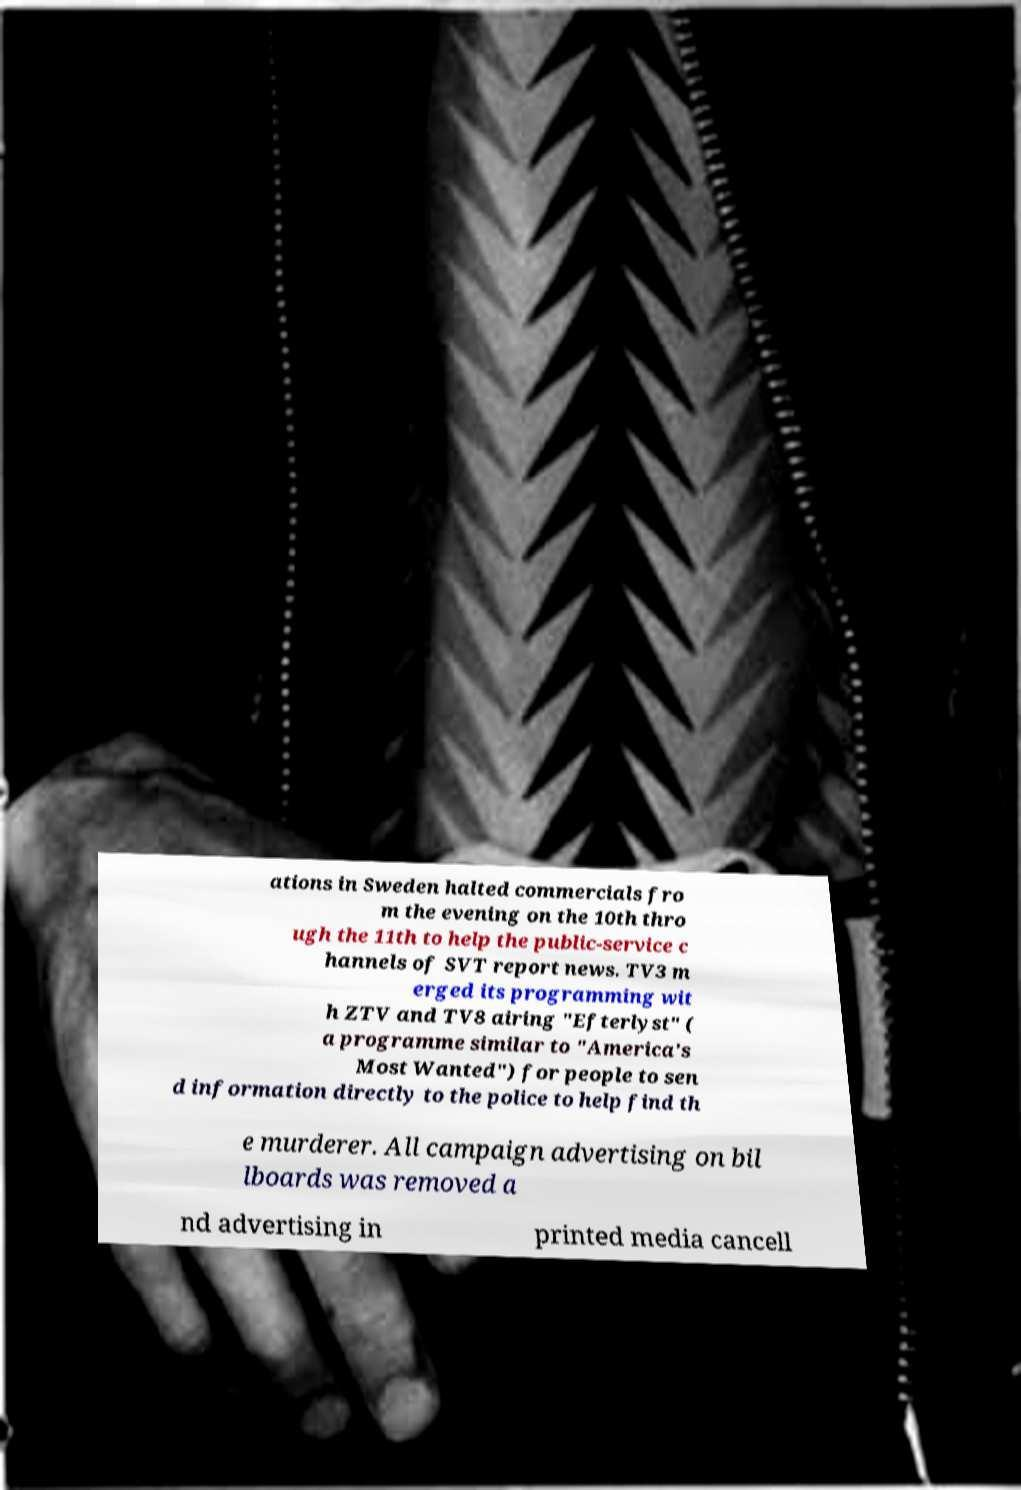There's text embedded in this image that I need extracted. Can you transcribe it verbatim? ations in Sweden halted commercials fro m the evening on the 10th thro ugh the 11th to help the public-service c hannels of SVT report news. TV3 m erged its programming wit h ZTV and TV8 airing "Efterlyst" ( a programme similar to "America's Most Wanted") for people to sen d information directly to the police to help find th e murderer. All campaign advertising on bil lboards was removed a nd advertising in printed media cancell 